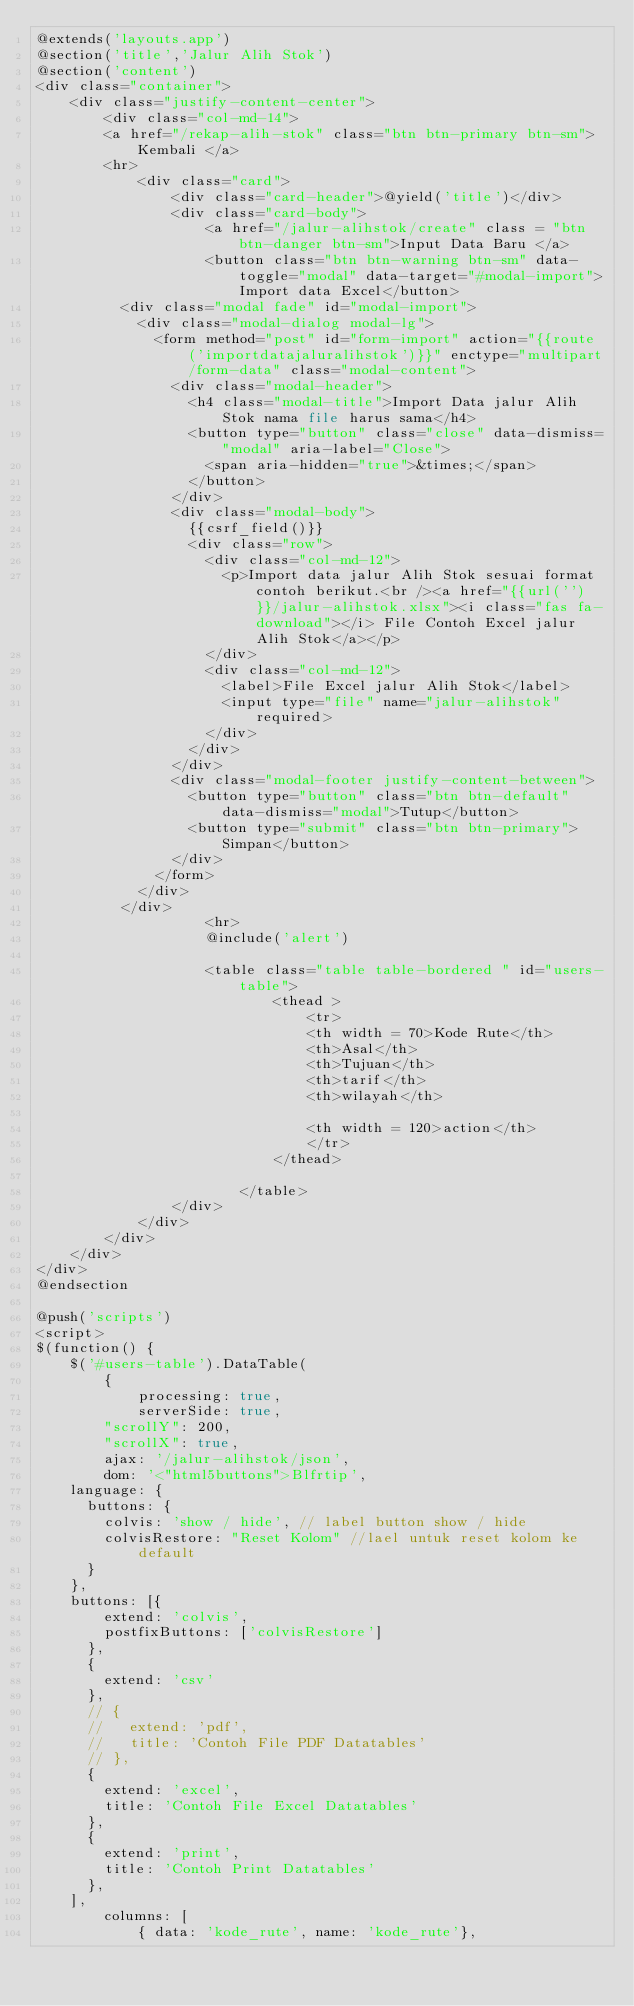Convert code to text. <code><loc_0><loc_0><loc_500><loc_500><_PHP_>@extends('layouts.app')
@section('title','Jalur Alih Stok')
@section('content')
<div class="container">
    <div class="justify-content-center">
        <div class="col-md-14">
        <a href="/rekap-alih-stok" class="btn btn-primary btn-sm">Kembali </a> 
        <hr> 
            <div class="card">
                <div class="card-header">@yield('title')</div>
                <div class="card-body">
                    <a href="/jalur-alihstok/create" class = "btn btn-danger btn-sm">Input Data Baru </a>
                    <button class="btn btn-warning btn-sm" data-toggle="modal" data-target="#modal-import">Import data Excel</button>
          <div class="modal fade" id="modal-import">
            <div class="modal-dialog modal-lg">
              <form method="post" id="form-import" action="{{route('importdatajaluralihstok')}}" enctype="multipart/form-data" class="modal-content">
                <div class="modal-header">
                  <h4 class="modal-title">Import Data jalur Alih Stok nama file harus sama</h4>
                  <button type="button" class="close" data-dismiss="modal" aria-label="Close">
                    <span aria-hidden="true">&times;</span>
                  </button>
                </div>
                <div class="modal-body">
                  {{csrf_field()}}
                  <div class="row">
                    <div class="col-md-12">
                      <p>Import data jalur Alih Stok sesuai format contoh berikut.<br /><a href="{{url('')}}/jalur-alihstok.xlsx"><i class="fas fa-download"></i> File Contoh Excel jalur Alih Stok</a></p>
                    </div>
                    <div class="col-md-12">
                      <label>File Excel jalur Alih Stok</label>
                      <input type="file" name="jalur-alihstok" required>
                    </div>
                  </div>
                </div>
                <div class="modal-footer justify-content-between">
                  <button type="button" class="btn btn-default" data-dismiss="modal">Tutup</button>
                  <button type="submit" class="btn btn-primary">Simpan</button>
                </div>
              </form>
            </div>
          </div>
                    <hr>
                    @include('alert')
                    
                    <table class="table table-bordered " id="users-table">
                            <thead >
                                <tr>
                                <th width = 70>Kode Rute</th>
                                <th>Asal</th>
                                <th>Tujuan</th>
                                <th>tarif</th>
                                <th>wilayah</th>
                                
                                <th width = 120>action</th>                                                                                                
                                </tr>                                                                                                 
                            </thead>
                            
                        </table>
                </div>
            </div>
        </div>
    </div>
</div>
@endsection

@push('scripts')
<script>
$(function() {
    $('#users-table').DataTable(
        {
            processing: true,
            serverSide: true,
        "scrollY": 200,
        "scrollX": true,
        ajax: '/jalur-alihstok/json',
        dom: '<"html5buttons">Blfrtip',
    language: {
      buttons: {
        colvis: 'show / hide', // label button show / hide
        colvisRestore: "Reset Kolom" //lael untuk reset kolom ke default
      }
    },
    buttons: [{
        extend: 'colvis',
        postfixButtons: ['colvisRestore']
      },
      {
        extend: 'csv'
      },
      // {
      //   extend: 'pdf',
      //   title: 'Contoh File PDF Datatables'
      // },
      {
        extend: 'excel',
        title: 'Contoh File Excel Datatables'
      },
      {
        extend: 'print',
        title: 'Contoh Print Datatables'
      },
    ],
        columns: [
            { data: 'kode_rute', name: 'kode_rute'},</code> 